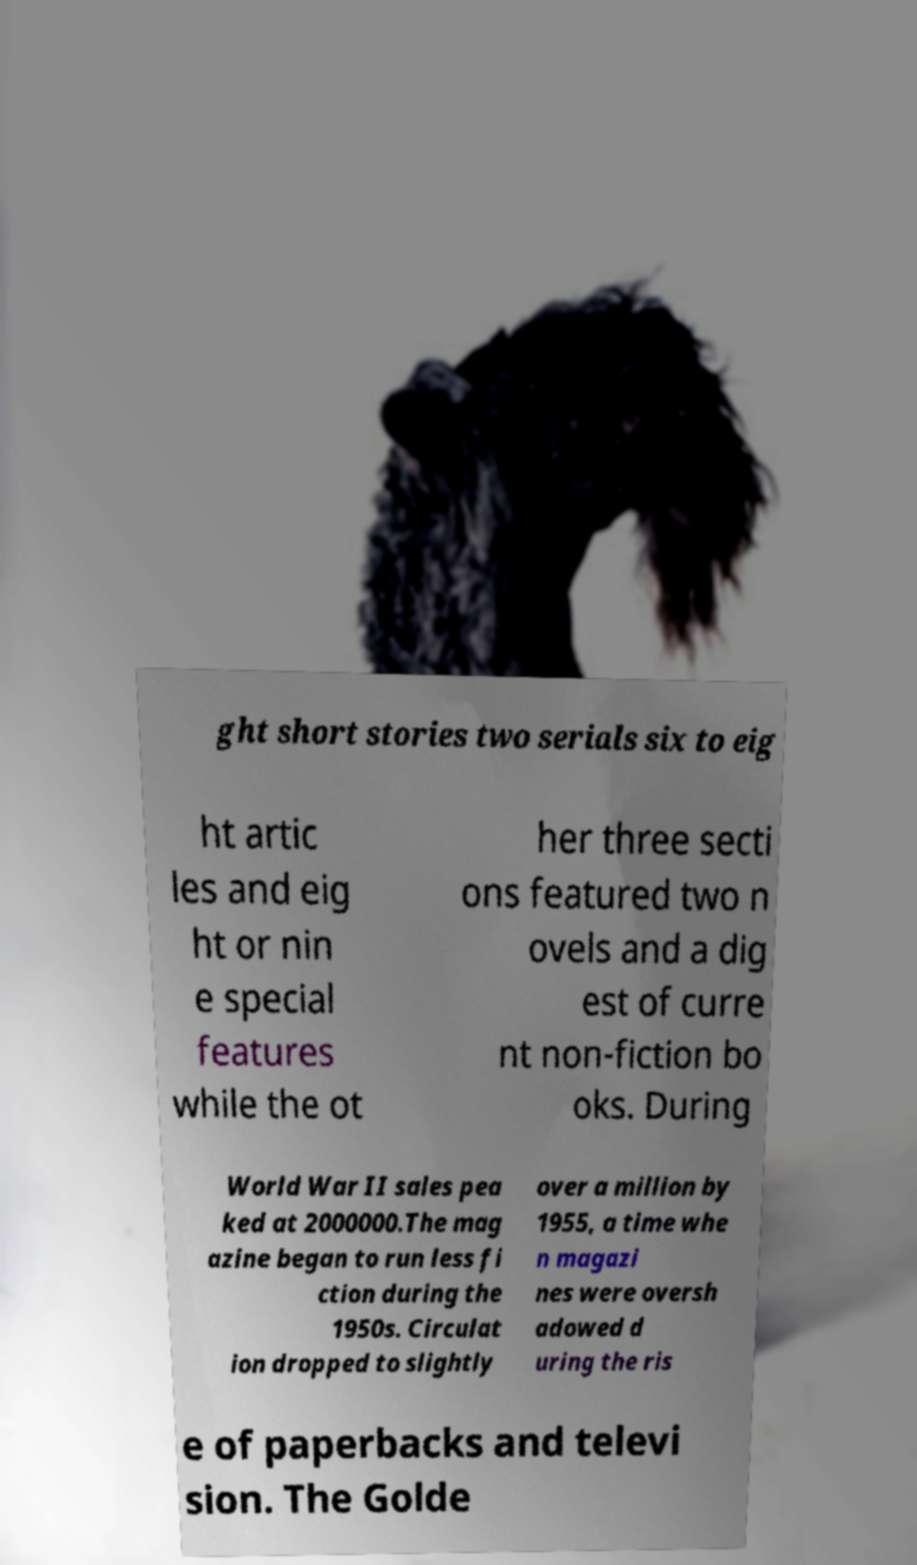I need the written content from this picture converted into text. Can you do that? ght short stories two serials six to eig ht artic les and eig ht or nin e special features while the ot her three secti ons featured two n ovels and a dig est of curre nt non-fiction bo oks. During World War II sales pea ked at 2000000.The mag azine began to run less fi ction during the 1950s. Circulat ion dropped to slightly over a million by 1955, a time whe n magazi nes were oversh adowed d uring the ris e of paperbacks and televi sion. The Golde 